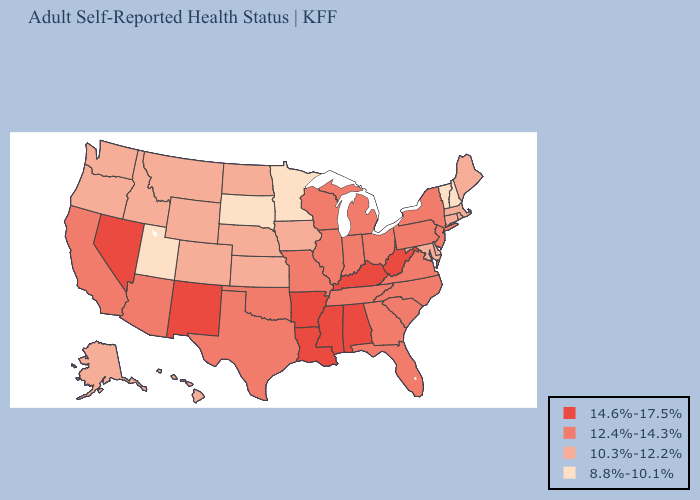Name the states that have a value in the range 10.3%-12.2%?
Quick response, please. Alaska, Colorado, Connecticut, Delaware, Hawaii, Idaho, Iowa, Kansas, Maine, Maryland, Massachusetts, Montana, Nebraska, North Dakota, Oregon, Rhode Island, Washington, Wyoming. Does the map have missing data?
Short answer required. No. What is the highest value in states that border Illinois?
Give a very brief answer. 14.6%-17.5%. Among the states that border North Dakota , which have the lowest value?
Keep it brief. Minnesota, South Dakota. Name the states that have a value in the range 12.4%-14.3%?
Answer briefly. Arizona, California, Florida, Georgia, Illinois, Indiana, Michigan, Missouri, New Jersey, New York, North Carolina, Ohio, Oklahoma, Pennsylvania, South Carolina, Tennessee, Texas, Virginia, Wisconsin. Which states have the lowest value in the MidWest?
Concise answer only. Minnesota, South Dakota. What is the value of Rhode Island?
Answer briefly. 10.3%-12.2%. Name the states that have a value in the range 14.6%-17.5%?
Give a very brief answer. Alabama, Arkansas, Kentucky, Louisiana, Mississippi, Nevada, New Mexico, West Virginia. Name the states that have a value in the range 14.6%-17.5%?
Answer briefly. Alabama, Arkansas, Kentucky, Louisiana, Mississippi, Nevada, New Mexico, West Virginia. Does the first symbol in the legend represent the smallest category?
Give a very brief answer. No. How many symbols are there in the legend?
Concise answer only. 4. Is the legend a continuous bar?
Write a very short answer. No. Among the states that border Georgia , does Tennessee have the highest value?
Quick response, please. No. What is the value of Florida?
Keep it brief. 12.4%-14.3%. 